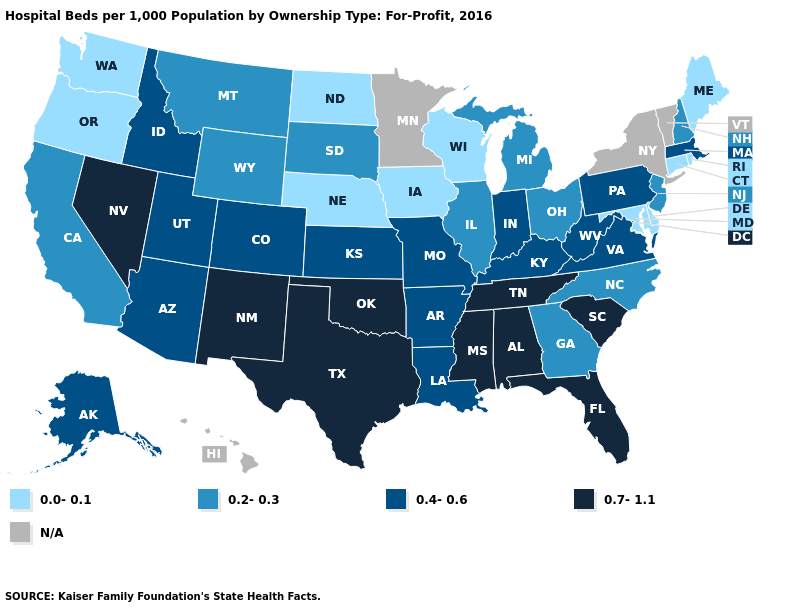Name the states that have a value in the range 0.4-0.6?
Concise answer only. Alaska, Arizona, Arkansas, Colorado, Idaho, Indiana, Kansas, Kentucky, Louisiana, Massachusetts, Missouri, Pennsylvania, Utah, Virginia, West Virginia. What is the value of Washington?
Give a very brief answer. 0.0-0.1. Does Delaware have the lowest value in the South?
Concise answer only. Yes. Name the states that have a value in the range 0.2-0.3?
Give a very brief answer. California, Georgia, Illinois, Michigan, Montana, New Hampshire, New Jersey, North Carolina, Ohio, South Dakota, Wyoming. Name the states that have a value in the range 0.4-0.6?
Answer briefly. Alaska, Arizona, Arkansas, Colorado, Idaho, Indiana, Kansas, Kentucky, Louisiana, Massachusetts, Missouri, Pennsylvania, Utah, Virginia, West Virginia. Name the states that have a value in the range 0.2-0.3?
Quick response, please. California, Georgia, Illinois, Michigan, Montana, New Hampshire, New Jersey, North Carolina, Ohio, South Dakota, Wyoming. What is the value of Connecticut?
Quick response, please. 0.0-0.1. What is the lowest value in states that border Arizona?
Write a very short answer. 0.2-0.3. Name the states that have a value in the range 0.4-0.6?
Be succinct. Alaska, Arizona, Arkansas, Colorado, Idaho, Indiana, Kansas, Kentucky, Louisiana, Massachusetts, Missouri, Pennsylvania, Utah, Virginia, West Virginia. Name the states that have a value in the range 0.2-0.3?
Concise answer only. California, Georgia, Illinois, Michigan, Montana, New Hampshire, New Jersey, North Carolina, Ohio, South Dakota, Wyoming. What is the lowest value in the MidWest?
Concise answer only. 0.0-0.1. What is the value of Maryland?
Answer briefly. 0.0-0.1. Which states have the lowest value in the USA?
Short answer required. Connecticut, Delaware, Iowa, Maine, Maryland, Nebraska, North Dakota, Oregon, Rhode Island, Washington, Wisconsin. 